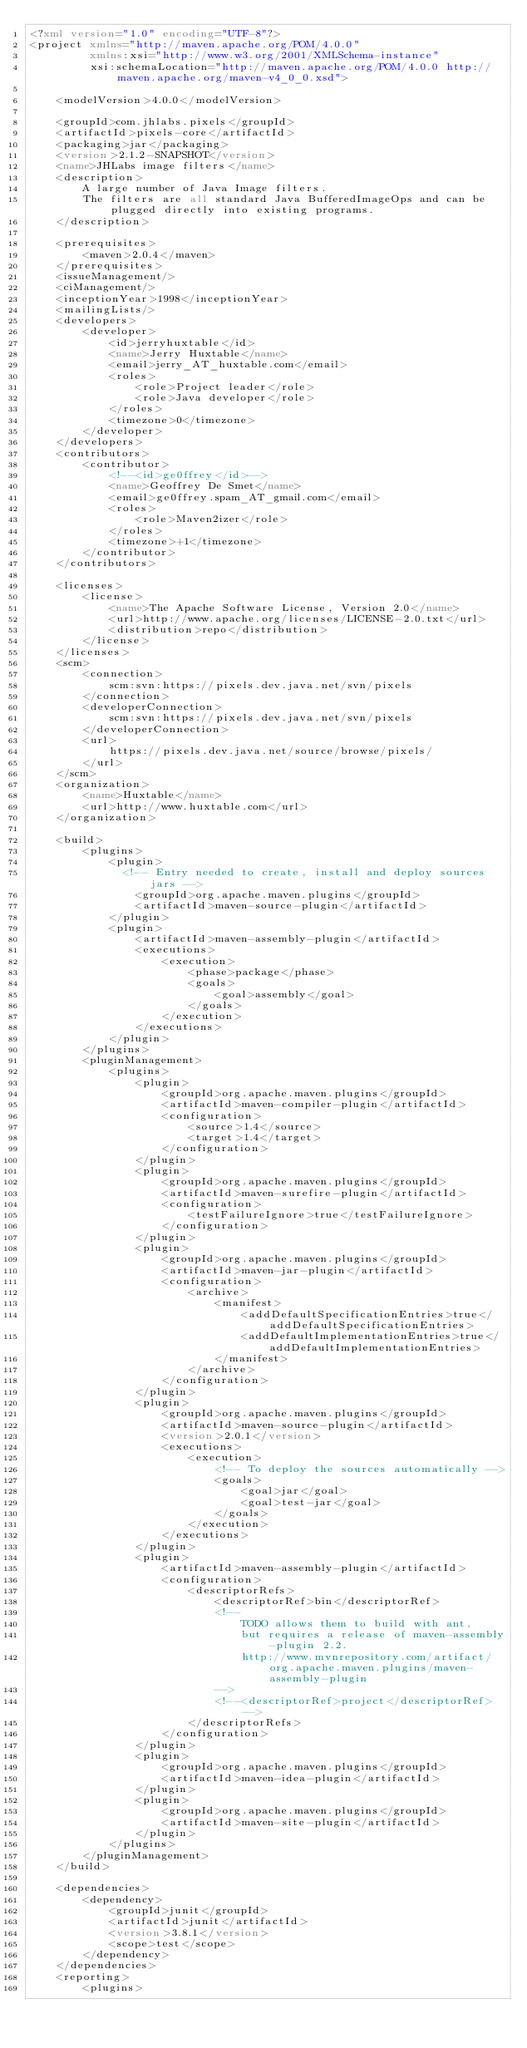<code> <loc_0><loc_0><loc_500><loc_500><_XML_><?xml version="1.0" encoding="UTF-8"?>
<project xmlns="http://maven.apache.org/POM/4.0.0"
         xmlns:xsi="http://www.w3.org/2001/XMLSchema-instance"
         xsi:schemaLocation="http://maven.apache.org/POM/4.0.0 http://maven.apache.org/maven-v4_0_0.xsd">

    <modelVersion>4.0.0</modelVersion>

    <groupId>com.jhlabs.pixels</groupId>
    <artifactId>pixels-core</artifactId>
    <packaging>jar</packaging>
    <version>2.1.2-SNAPSHOT</version>
    <name>JHLabs image filters</name>
    <description>
        A large number of Java Image filters.
        The filters are all standard Java BufferedImageOps and can be plugged directly into existing programs.
    </description>

    <prerequisites>
        <maven>2.0.4</maven>
    </prerequisites>
    <issueManagement/>
    <ciManagement/>
    <inceptionYear>1998</inceptionYear>
    <mailingLists/>
    <developers>
        <developer>
            <id>jerryhuxtable</id>
            <name>Jerry Huxtable</name>
            <email>jerry_AT_huxtable.com</email>
            <roles>
                <role>Project leader</role>
                <role>Java developer</role>
            </roles>
            <timezone>0</timezone>
        </developer>
    </developers>
    <contributors>
        <contributor>
            <!--<id>ge0ffrey</id>-->
            <name>Geoffrey De Smet</name>
            <email>ge0ffrey.spam_AT_gmail.com</email>
            <roles>
                <role>Maven2izer</role>
            </roles>
            <timezone>+1</timezone>
        </contributor>
    </contributors>

    <licenses>
        <license>
            <name>The Apache Software License, Version 2.0</name>
            <url>http://www.apache.org/licenses/LICENSE-2.0.txt</url>
            <distribution>repo</distribution>
        </license>
    </licenses>
    <scm>
        <connection>
            scm:svn:https://pixels.dev.java.net/svn/pixels
        </connection>
        <developerConnection>
            scm:svn:https://pixels.dev.java.net/svn/pixels
        </developerConnection>
        <url>
            https://pixels.dev.java.net/source/browse/pixels/
        </url>
    </scm>
    <organization>
        <name>Huxtable</name>
        <url>http://www.huxtable.com</url>
    </organization>

    <build>
        <plugins>
            <plugin>
              <!-- Entry needed to create, install and deploy sources jars -->
                <groupId>org.apache.maven.plugins</groupId>
                <artifactId>maven-source-plugin</artifactId>
            </plugin>
            <plugin>
                <artifactId>maven-assembly-plugin</artifactId>
                <executions>
                    <execution>
                        <phase>package</phase>
                        <goals>
                            <goal>assembly</goal>
                        </goals>
                    </execution>
                </executions>
            </plugin>
        </plugins>
        <pluginManagement>
            <plugins>
                <plugin>
                    <groupId>org.apache.maven.plugins</groupId>
                    <artifactId>maven-compiler-plugin</artifactId>
                    <configuration>
                        <source>1.4</source>
                        <target>1.4</target>
                    </configuration>
                </plugin>
                <plugin>
                    <groupId>org.apache.maven.plugins</groupId>
                    <artifactId>maven-surefire-plugin</artifactId>
                    <configuration>
                        <testFailureIgnore>true</testFailureIgnore>
                    </configuration>
                </plugin>
                <plugin>
                    <groupId>org.apache.maven.plugins</groupId>
                    <artifactId>maven-jar-plugin</artifactId>
                    <configuration>
                        <archive>
                            <manifest>
                                <addDefaultSpecificationEntries>true</addDefaultSpecificationEntries>
                                <addDefaultImplementationEntries>true</addDefaultImplementationEntries>
                            </manifest>
                        </archive>
                    </configuration>
                </plugin>
                <plugin>
                    <groupId>org.apache.maven.plugins</groupId>
                    <artifactId>maven-source-plugin</artifactId>
                    <version>2.0.1</version>
                    <executions>
                        <execution>
                            <!-- To deploy the sources automatically -->
                            <goals>
                                <goal>jar</goal>
                                <goal>test-jar</goal>
                            </goals>
                        </execution>
                    </executions>
                </plugin>
                <plugin>
                    <artifactId>maven-assembly-plugin</artifactId>
                    <configuration>
                        <descriptorRefs>
                            <descriptorRef>bin</descriptorRef>
                            <!--
                                TODO allows them to build with ant,
                                but requires a release of maven-assembly-plugin 2.2.
                                http://www.mvnrepository.com/artifact/org.apache.maven.plugins/maven-assembly-plugin
                            -->
                            <!--<descriptorRef>project</descriptorRef>-->
                        </descriptorRefs>
                    </configuration>
                </plugin>
                <plugin>
                    <groupId>org.apache.maven.plugins</groupId>
                    <artifactId>maven-idea-plugin</artifactId>
                </plugin>
                <plugin>
                    <groupId>org.apache.maven.plugins</groupId>
                    <artifactId>maven-site-plugin</artifactId>
                </plugin>
            </plugins>
        </pluginManagement>
    </build>

    <dependencies>
        <dependency>
            <groupId>junit</groupId>
            <artifactId>junit</artifactId>
            <version>3.8.1</version>
            <scope>test</scope>
        </dependency>
    </dependencies>
    <reporting>
        <plugins></code> 